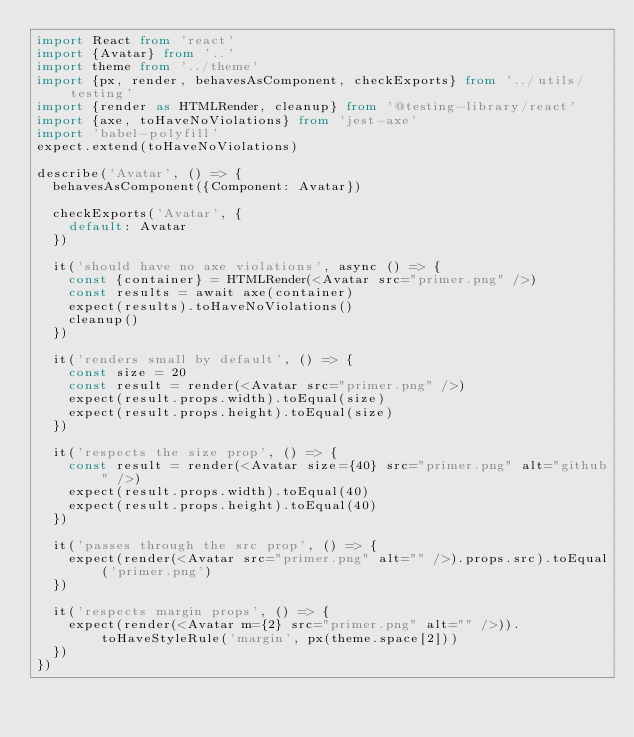Convert code to text. <code><loc_0><loc_0><loc_500><loc_500><_TypeScript_>import React from 'react'
import {Avatar} from '..'
import theme from '../theme'
import {px, render, behavesAsComponent, checkExports} from '../utils/testing'
import {render as HTMLRender, cleanup} from '@testing-library/react'
import {axe, toHaveNoViolations} from 'jest-axe'
import 'babel-polyfill'
expect.extend(toHaveNoViolations)

describe('Avatar', () => {
  behavesAsComponent({Component: Avatar})

  checkExports('Avatar', {
    default: Avatar
  })

  it('should have no axe violations', async () => {
    const {container} = HTMLRender(<Avatar src="primer.png" />)
    const results = await axe(container)
    expect(results).toHaveNoViolations()
    cleanup()
  })

  it('renders small by default', () => {
    const size = 20
    const result = render(<Avatar src="primer.png" />)
    expect(result.props.width).toEqual(size)
    expect(result.props.height).toEqual(size)
  })

  it('respects the size prop', () => {
    const result = render(<Avatar size={40} src="primer.png" alt="github" />)
    expect(result.props.width).toEqual(40)
    expect(result.props.height).toEqual(40)
  })

  it('passes through the src prop', () => {
    expect(render(<Avatar src="primer.png" alt="" />).props.src).toEqual('primer.png')
  })

  it('respects margin props', () => {
    expect(render(<Avatar m={2} src="primer.png" alt="" />)).toHaveStyleRule('margin', px(theme.space[2]))
  })
})
</code> 